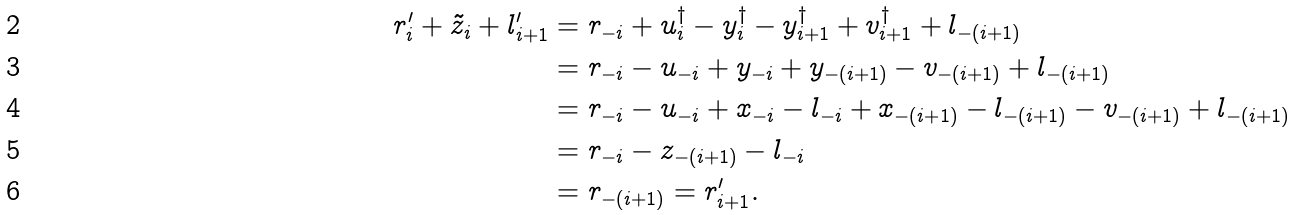<formula> <loc_0><loc_0><loc_500><loc_500>r ^ { \prime } _ { i } + \tilde { z } _ { i } + l ^ { \prime } _ { i + 1 } & = r _ { - i } + u ^ { \dag } _ { i } - y ^ { \dag } _ { i } - y ^ { \dag } _ { i + 1 } + v ^ { \dag } _ { i + 1 } + l _ { - ( i + 1 ) } \\ & = r _ { - i } - u _ { - i } + y _ { - i } + y _ { - ( i + 1 ) } - v _ { - ( i + 1 ) } + l _ { - ( i + 1 ) } \\ & = r _ { - i } - u _ { - i } + x _ { - i } - l _ { - i } + x _ { - ( i + 1 ) } - l _ { - ( i + 1 ) } - v _ { - ( i + 1 ) } + l _ { - ( i + 1 ) } \\ & = r _ { - i } - z _ { - ( i + 1 ) } - l _ { - i } \\ & = r _ { - ( i + 1 ) } = r ^ { \prime } _ { i + 1 } .</formula> 